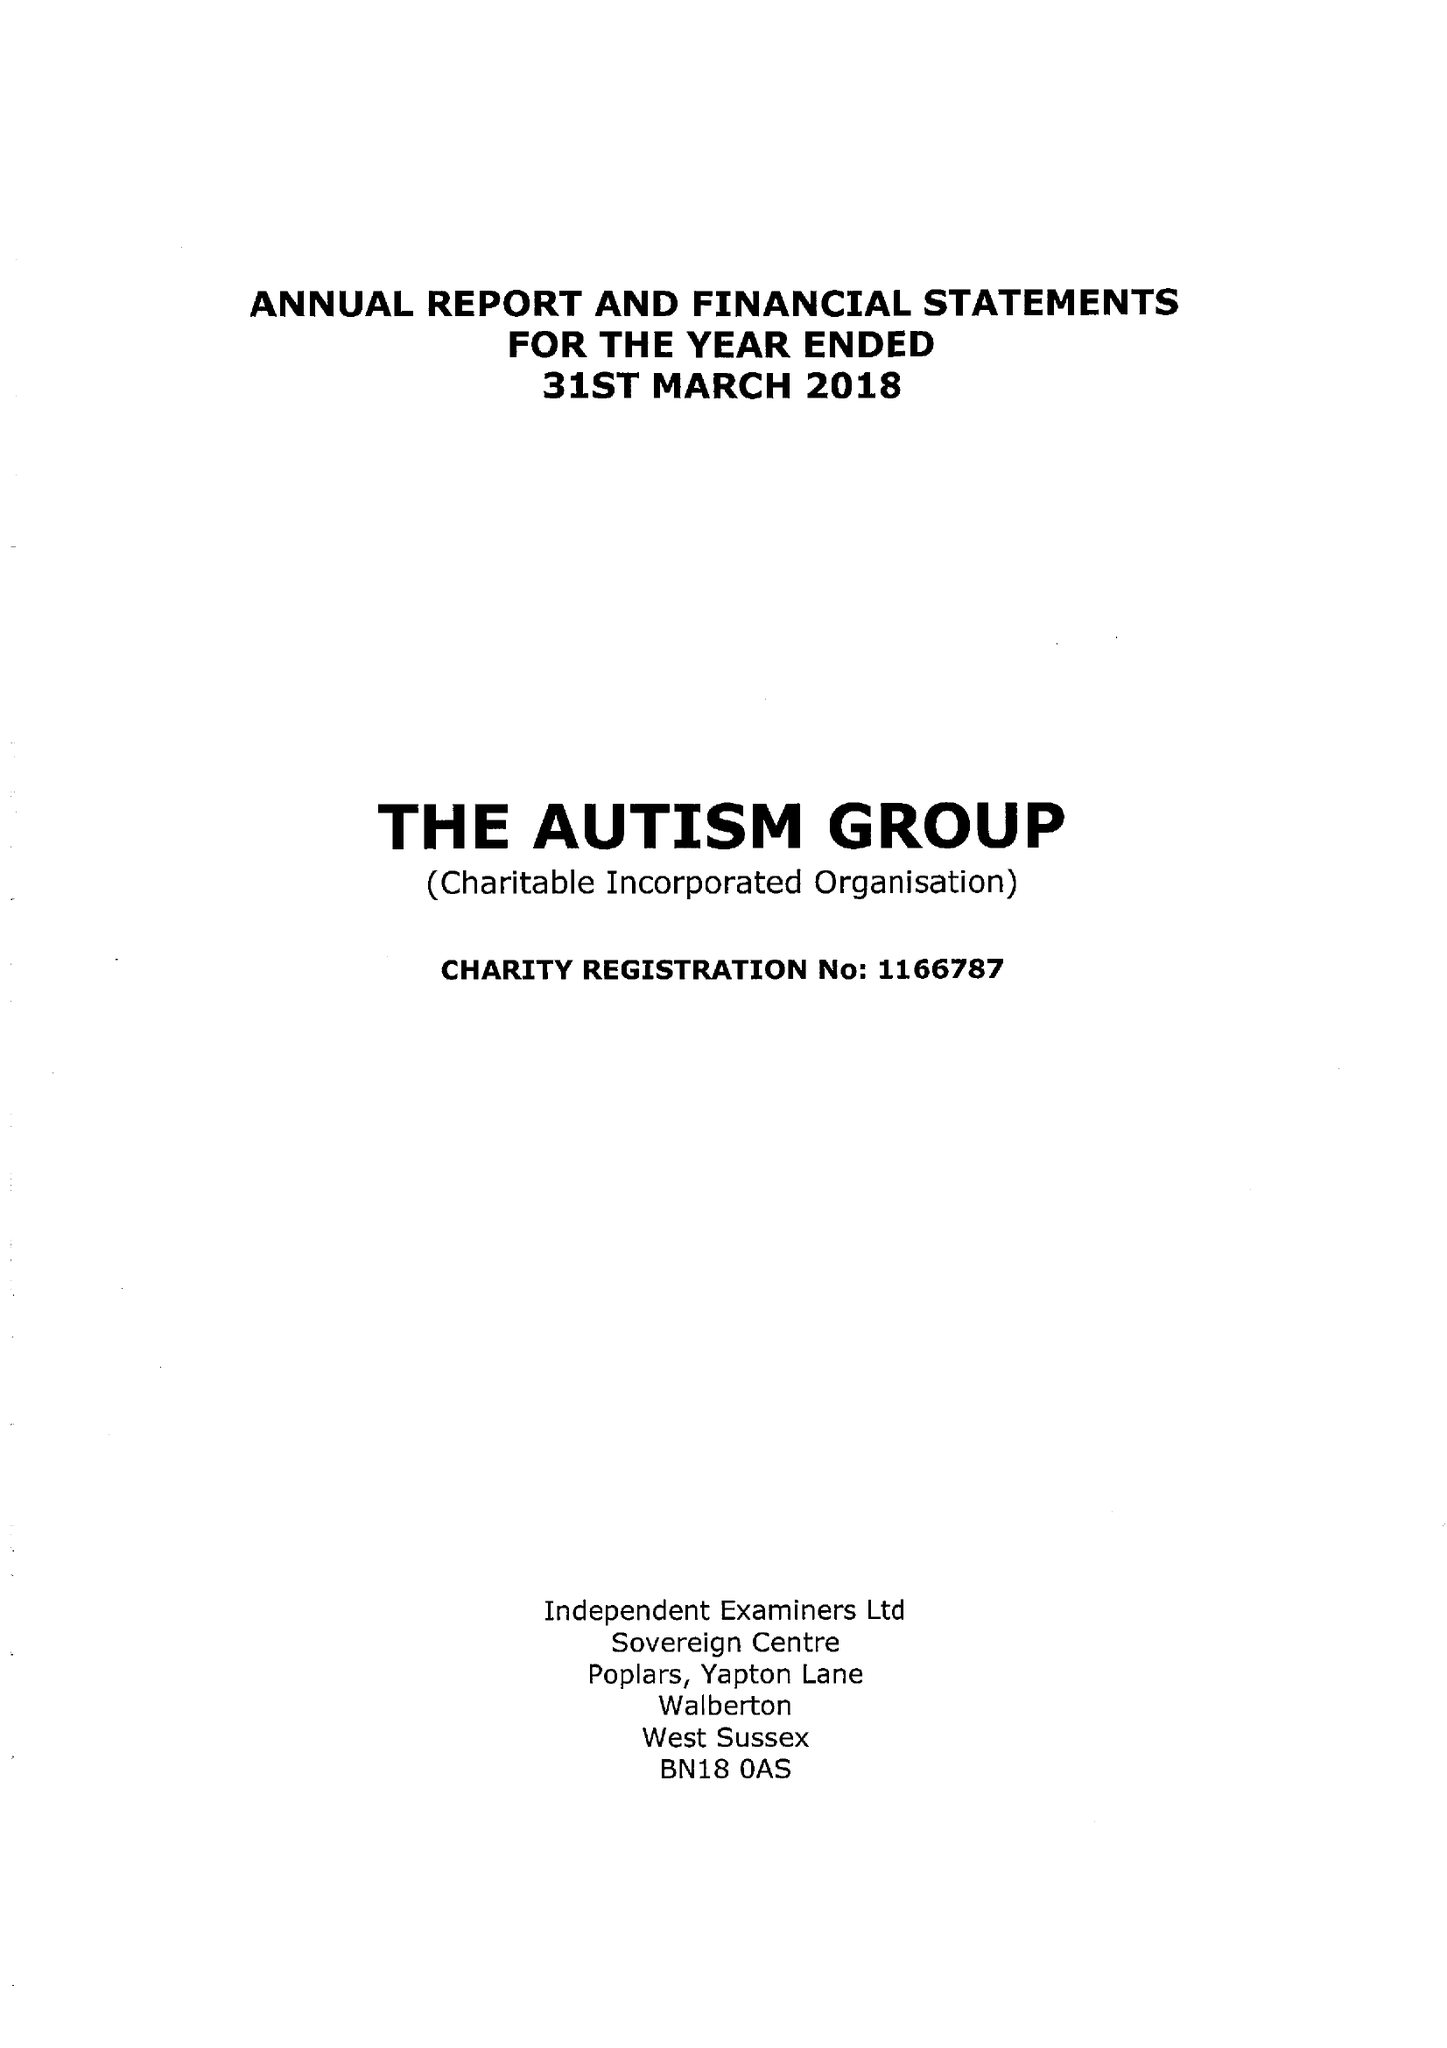What is the value for the charity_name?
Answer the question using a single word or phrase. The Autism Group 